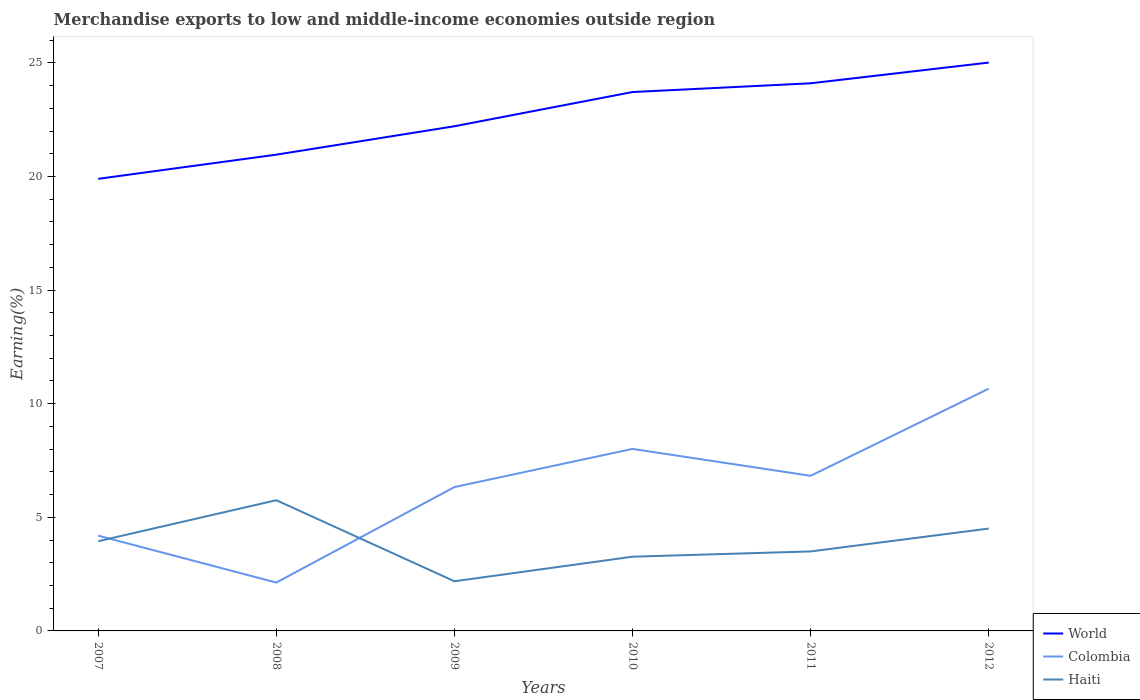Does the line corresponding to Haiti intersect with the line corresponding to World?
Your answer should be compact. No. Is the number of lines equal to the number of legend labels?
Your response must be concise. Yes. Across all years, what is the maximum percentage of amount earned from merchandise exports in Colombia?
Provide a succinct answer. 2.13. What is the total percentage of amount earned from merchandise exports in World in the graph?
Offer a very short reply. -3.82. What is the difference between the highest and the second highest percentage of amount earned from merchandise exports in World?
Your response must be concise. 5.12. What is the difference between the highest and the lowest percentage of amount earned from merchandise exports in Haiti?
Provide a succinct answer. 3. Is the percentage of amount earned from merchandise exports in Haiti strictly greater than the percentage of amount earned from merchandise exports in World over the years?
Provide a short and direct response. Yes. How many lines are there?
Ensure brevity in your answer.  3. Are the values on the major ticks of Y-axis written in scientific E-notation?
Provide a succinct answer. No. What is the title of the graph?
Offer a terse response. Merchandise exports to low and middle-income economies outside region. Does "Hungary" appear as one of the legend labels in the graph?
Offer a terse response. No. What is the label or title of the X-axis?
Give a very brief answer. Years. What is the label or title of the Y-axis?
Give a very brief answer. Earning(%). What is the Earning(%) in World in 2007?
Your answer should be very brief. 19.9. What is the Earning(%) in Colombia in 2007?
Provide a succinct answer. 4.19. What is the Earning(%) of Haiti in 2007?
Provide a succinct answer. 3.95. What is the Earning(%) in World in 2008?
Make the answer very short. 20.96. What is the Earning(%) in Colombia in 2008?
Offer a terse response. 2.13. What is the Earning(%) in Haiti in 2008?
Offer a terse response. 5.75. What is the Earning(%) in World in 2009?
Your answer should be compact. 22.21. What is the Earning(%) in Colombia in 2009?
Make the answer very short. 6.33. What is the Earning(%) in Haiti in 2009?
Provide a short and direct response. 2.19. What is the Earning(%) in World in 2010?
Your response must be concise. 23.72. What is the Earning(%) in Colombia in 2010?
Offer a terse response. 8.01. What is the Earning(%) in Haiti in 2010?
Provide a succinct answer. 3.27. What is the Earning(%) in World in 2011?
Your answer should be very brief. 24.1. What is the Earning(%) of Colombia in 2011?
Your answer should be compact. 6.83. What is the Earning(%) in Haiti in 2011?
Your answer should be compact. 3.5. What is the Earning(%) of World in 2012?
Give a very brief answer. 25.01. What is the Earning(%) in Colombia in 2012?
Your response must be concise. 10.66. What is the Earning(%) in Haiti in 2012?
Make the answer very short. 4.51. Across all years, what is the maximum Earning(%) of World?
Your answer should be compact. 25.01. Across all years, what is the maximum Earning(%) of Colombia?
Your response must be concise. 10.66. Across all years, what is the maximum Earning(%) of Haiti?
Your answer should be very brief. 5.75. Across all years, what is the minimum Earning(%) of World?
Offer a terse response. 19.9. Across all years, what is the minimum Earning(%) of Colombia?
Give a very brief answer. 2.13. Across all years, what is the minimum Earning(%) of Haiti?
Keep it short and to the point. 2.19. What is the total Earning(%) of World in the graph?
Make the answer very short. 135.9. What is the total Earning(%) of Colombia in the graph?
Your response must be concise. 38.15. What is the total Earning(%) of Haiti in the graph?
Make the answer very short. 23.16. What is the difference between the Earning(%) in World in 2007 and that in 2008?
Your answer should be very brief. -1.06. What is the difference between the Earning(%) in Colombia in 2007 and that in 2008?
Make the answer very short. 2.06. What is the difference between the Earning(%) of Haiti in 2007 and that in 2008?
Your response must be concise. -1.8. What is the difference between the Earning(%) of World in 2007 and that in 2009?
Give a very brief answer. -2.31. What is the difference between the Earning(%) of Colombia in 2007 and that in 2009?
Provide a short and direct response. -2.14. What is the difference between the Earning(%) of Haiti in 2007 and that in 2009?
Offer a very short reply. 1.76. What is the difference between the Earning(%) of World in 2007 and that in 2010?
Your response must be concise. -3.82. What is the difference between the Earning(%) of Colombia in 2007 and that in 2010?
Offer a very short reply. -3.82. What is the difference between the Earning(%) of Haiti in 2007 and that in 2010?
Offer a terse response. 0.68. What is the difference between the Earning(%) in World in 2007 and that in 2011?
Make the answer very short. -4.2. What is the difference between the Earning(%) of Colombia in 2007 and that in 2011?
Make the answer very short. -2.63. What is the difference between the Earning(%) of Haiti in 2007 and that in 2011?
Your response must be concise. 0.45. What is the difference between the Earning(%) of World in 2007 and that in 2012?
Keep it short and to the point. -5.12. What is the difference between the Earning(%) in Colombia in 2007 and that in 2012?
Your answer should be very brief. -6.47. What is the difference between the Earning(%) of Haiti in 2007 and that in 2012?
Your response must be concise. -0.56. What is the difference between the Earning(%) of World in 2008 and that in 2009?
Give a very brief answer. -1.25. What is the difference between the Earning(%) in Colombia in 2008 and that in 2009?
Provide a succinct answer. -4.2. What is the difference between the Earning(%) in Haiti in 2008 and that in 2009?
Provide a succinct answer. 3.57. What is the difference between the Earning(%) of World in 2008 and that in 2010?
Keep it short and to the point. -2.76. What is the difference between the Earning(%) in Colombia in 2008 and that in 2010?
Provide a succinct answer. -5.88. What is the difference between the Earning(%) in Haiti in 2008 and that in 2010?
Your answer should be very brief. 2.49. What is the difference between the Earning(%) in World in 2008 and that in 2011?
Offer a terse response. -3.14. What is the difference between the Earning(%) in Colombia in 2008 and that in 2011?
Your answer should be very brief. -4.7. What is the difference between the Earning(%) of Haiti in 2008 and that in 2011?
Your answer should be compact. 2.25. What is the difference between the Earning(%) in World in 2008 and that in 2012?
Provide a succinct answer. -4.05. What is the difference between the Earning(%) of Colombia in 2008 and that in 2012?
Offer a terse response. -8.53. What is the difference between the Earning(%) in Haiti in 2008 and that in 2012?
Provide a short and direct response. 1.25. What is the difference between the Earning(%) in World in 2009 and that in 2010?
Keep it short and to the point. -1.51. What is the difference between the Earning(%) in Colombia in 2009 and that in 2010?
Offer a terse response. -1.68. What is the difference between the Earning(%) of Haiti in 2009 and that in 2010?
Your answer should be compact. -1.08. What is the difference between the Earning(%) in World in 2009 and that in 2011?
Give a very brief answer. -1.89. What is the difference between the Earning(%) of Colombia in 2009 and that in 2011?
Make the answer very short. -0.49. What is the difference between the Earning(%) of Haiti in 2009 and that in 2011?
Give a very brief answer. -1.31. What is the difference between the Earning(%) of World in 2009 and that in 2012?
Make the answer very short. -2.8. What is the difference between the Earning(%) of Colombia in 2009 and that in 2012?
Keep it short and to the point. -4.33. What is the difference between the Earning(%) in Haiti in 2009 and that in 2012?
Your response must be concise. -2.32. What is the difference between the Earning(%) in World in 2010 and that in 2011?
Ensure brevity in your answer.  -0.38. What is the difference between the Earning(%) in Colombia in 2010 and that in 2011?
Provide a succinct answer. 1.18. What is the difference between the Earning(%) of Haiti in 2010 and that in 2011?
Give a very brief answer. -0.23. What is the difference between the Earning(%) of World in 2010 and that in 2012?
Your answer should be very brief. -1.3. What is the difference between the Earning(%) of Colombia in 2010 and that in 2012?
Your answer should be compact. -2.65. What is the difference between the Earning(%) of Haiti in 2010 and that in 2012?
Offer a very short reply. -1.24. What is the difference between the Earning(%) in World in 2011 and that in 2012?
Offer a terse response. -0.91. What is the difference between the Earning(%) of Colombia in 2011 and that in 2012?
Provide a short and direct response. -3.83. What is the difference between the Earning(%) of Haiti in 2011 and that in 2012?
Give a very brief answer. -1.01. What is the difference between the Earning(%) in World in 2007 and the Earning(%) in Colombia in 2008?
Your answer should be very brief. 17.77. What is the difference between the Earning(%) in World in 2007 and the Earning(%) in Haiti in 2008?
Provide a short and direct response. 14.14. What is the difference between the Earning(%) in Colombia in 2007 and the Earning(%) in Haiti in 2008?
Keep it short and to the point. -1.56. What is the difference between the Earning(%) of World in 2007 and the Earning(%) of Colombia in 2009?
Offer a very short reply. 13.57. What is the difference between the Earning(%) in World in 2007 and the Earning(%) in Haiti in 2009?
Keep it short and to the point. 17.71. What is the difference between the Earning(%) in Colombia in 2007 and the Earning(%) in Haiti in 2009?
Your answer should be very brief. 2.01. What is the difference between the Earning(%) in World in 2007 and the Earning(%) in Colombia in 2010?
Ensure brevity in your answer.  11.89. What is the difference between the Earning(%) of World in 2007 and the Earning(%) of Haiti in 2010?
Keep it short and to the point. 16.63. What is the difference between the Earning(%) of Colombia in 2007 and the Earning(%) of Haiti in 2010?
Your answer should be very brief. 0.93. What is the difference between the Earning(%) of World in 2007 and the Earning(%) of Colombia in 2011?
Your answer should be compact. 13.07. What is the difference between the Earning(%) of World in 2007 and the Earning(%) of Haiti in 2011?
Provide a short and direct response. 16.4. What is the difference between the Earning(%) in Colombia in 2007 and the Earning(%) in Haiti in 2011?
Your answer should be very brief. 0.69. What is the difference between the Earning(%) of World in 2007 and the Earning(%) of Colombia in 2012?
Your answer should be very brief. 9.24. What is the difference between the Earning(%) in World in 2007 and the Earning(%) in Haiti in 2012?
Your response must be concise. 15.39. What is the difference between the Earning(%) of Colombia in 2007 and the Earning(%) of Haiti in 2012?
Your answer should be compact. -0.31. What is the difference between the Earning(%) of World in 2008 and the Earning(%) of Colombia in 2009?
Your response must be concise. 14.63. What is the difference between the Earning(%) of World in 2008 and the Earning(%) of Haiti in 2009?
Provide a short and direct response. 18.77. What is the difference between the Earning(%) in Colombia in 2008 and the Earning(%) in Haiti in 2009?
Offer a very short reply. -0.06. What is the difference between the Earning(%) in World in 2008 and the Earning(%) in Colombia in 2010?
Ensure brevity in your answer.  12.95. What is the difference between the Earning(%) in World in 2008 and the Earning(%) in Haiti in 2010?
Your answer should be compact. 17.69. What is the difference between the Earning(%) in Colombia in 2008 and the Earning(%) in Haiti in 2010?
Ensure brevity in your answer.  -1.14. What is the difference between the Earning(%) in World in 2008 and the Earning(%) in Colombia in 2011?
Provide a succinct answer. 14.13. What is the difference between the Earning(%) of World in 2008 and the Earning(%) of Haiti in 2011?
Offer a very short reply. 17.46. What is the difference between the Earning(%) of Colombia in 2008 and the Earning(%) of Haiti in 2011?
Ensure brevity in your answer.  -1.37. What is the difference between the Earning(%) of World in 2008 and the Earning(%) of Haiti in 2012?
Offer a very short reply. 16.45. What is the difference between the Earning(%) of Colombia in 2008 and the Earning(%) of Haiti in 2012?
Give a very brief answer. -2.38. What is the difference between the Earning(%) of World in 2009 and the Earning(%) of Colombia in 2010?
Ensure brevity in your answer.  14.2. What is the difference between the Earning(%) in World in 2009 and the Earning(%) in Haiti in 2010?
Your response must be concise. 18.94. What is the difference between the Earning(%) of Colombia in 2009 and the Earning(%) of Haiti in 2010?
Your answer should be compact. 3.06. What is the difference between the Earning(%) in World in 2009 and the Earning(%) in Colombia in 2011?
Your response must be concise. 15.38. What is the difference between the Earning(%) of World in 2009 and the Earning(%) of Haiti in 2011?
Your answer should be compact. 18.71. What is the difference between the Earning(%) of Colombia in 2009 and the Earning(%) of Haiti in 2011?
Ensure brevity in your answer.  2.83. What is the difference between the Earning(%) of World in 2009 and the Earning(%) of Colombia in 2012?
Keep it short and to the point. 11.55. What is the difference between the Earning(%) in World in 2009 and the Earning(%) in Haiti in 2012?
Ensure brevity in your answer.  17.71. What is the difference between the Earning(%) in Colombia in 2009 and the Earning(%) in Haiti in 2012?
Ensure brevity in your answer.  1.83. What is the difference between the Earning(%) in World in 2010 and the Earning(%) in Colombia in 2011?
Your answer should be compact. 16.89. What is the difference between the Earning(%) in World in 2010 and the Earning(%) in Haiti in 2011?
Keep it short and to the point. 20.22. What is the difference between the Earning(%) of Colombia in 2010 and the Earning(%) of Haiti in 2011?
Give a very brief answer. 4.51. What is the difference between the Earning(%) in World in 2010 and the Earning(%) in Colombia in 2012?
Your answer should be very brief. 13.06. What is the difference between the Earning(%) in World in 2010 and the Earning(%) in Haiti in 2012?
Your answer should be compact. 19.21. What is the difference between the Earning(%) in Colombia in 2010 and the Earning(%) in Haiti in 2012?
Give a very brief answer. 3.51. What is the difference between the Earning(%) in World in 2011 and the Earning(%) in Colombia in 2012?
Your answer should be compact. 13.44. What is the difference between the Earning(%) in World in 2011 and the Earning(%) in Haiti in 2012?
Provide a succinct answer. 19.6. What is the difference between the Earning(%) in Colombia in 2011 and the Earning(%) in Haiti in 2012?
Provide a short and direct response. 2.32. What is the average Earning(%) in World per year?
Keep it short and to the point. 22.65. What is the average Earning(%) in Colombia per year?
Provide a short and direct response. 6.36. What is the average Earning(%) of Haiti per year?
Ensure brevity in your answer.  3.86. In the year 2007, what is the difference between the Earning(%) of World and Earning(%) of Colombia?
Ensure brevity in your answer.  15.7. In the year 2007, what is the difference between the Earning(%) in World and Earning(%) in Haiti?
Give a very brief answer. 15.95. In the year 2007, what is the difference between the Earning(%) of Colombia and Earning(%) of Haiti?
Your answer should be very brief. 0.24. In the year 2008, what is the difference between the Earning(%) in World and Earning(%) in Colombia?
Offer a terse response. 18.83. In the year 2008, what is the difference between the Earning(%) in World and Earning(%) in Haiti?
Ensure brevity in your answer.  15.21. In the year 2008, what is the difference between the Earning(%) of Colombia and Earning(%) of Haiti?
Keep it short and to the point. -3.62. In the year 2009, what is the difference between the Earning(%) in World and Earning(%) in Colombia?
Ensure brevity in your answer.  15.88. In the year 2009, what is the difference between the Earning(%) of World and Earning(%) of Haiti?
Give a very brief answer. 20.02. In the year 2009, what is the difference between the Earning(%) of Colombia and Earning(%) of Haiti?
Provide a succinct answer. 4.15. In the year 2010, what is the difference between the Earning(%) of World and Earning(%) of Colombia?
Your answer should be very brief. 15.71. In the year 2010, what is the difference between the Earning(%) of World and Earning(%) of Haiti?
Keep it short and to the point. 20.45. In the year 2010, what is the difference between the Earning(%) of Colombia and Earning(%) of Haiti?
Your response must be concise. 4.74. In the year 2011, what is the difference between the Earning(%) of World and Earning(%) of Colombia?
Ensure brevity in your answer.  17.27. In the year 2011, what is the difference between the Earning(%) in World and Earning(%) in Haiti?
Ensure brevity in your answer.  20.6. In the year 2011, what is the difference between the Earning(%) in Colombia and Earning(%) in Haiti?
Ensure brevity in your answer.  3.33. In the year 2012, what is the difference between the Earning(%) of World and Earning(%) of Colombia?
Keep it short and to the point. 14.35. In the year 2012, what is the difference between the Earning(%) of World and Earning(%) of Haiti?
Ensure brevity in your answer.  20.51. In the year 2012, what is the difference between the Earning(%) in Colombia and Earning(%) in Haiti?
Your answer should be compact. 6.15. What is the ratio of the Earning(%) of World in 2007 to that in 2008?
Provide a succinct answer. 0.95. What is the ratio of the Earning(%) in Colombia in 2007 to that in 2008?
Provide a short and direct response. 1.97. What is the ratio of the Earning(%) of Haiti in 2007 to that in 2008?
Ensure brevity in your answer.  0.69. What is the ratio of the Earning(%) in World in 2007 to that in 2009?
Your answer should be compact. 0.9. What is the ratio of the Earning(%) in Colombia in 2007 to that in 2009?
Ensure brevity in your answer.  0.66. What is the ratio of the Earning(%) in Haiti in 2007 to that in 2009?
Offer a very short reply. 1.81. What is the ratio of the Earning(%) of World in 2007 to that in 2010?
Keep it short and to the point. 0.84. What is the ratio of the Earning(%) of Colombia in 2007 to that in 2010?
Offer a very short reply. 0.52. What is the ratio of the Earning(%) of Haiti in 2007 to that in 2010?
Provide a short and direct response. 1.21. What is the ratio of the Earning(%) in World in 2007 to that in 2011?
Make the answer very short. 0.83. What is the ratio of the Earning(%) of Colombia in 2007 to that in 2011?
Your answer should be compact. 0.61. What is the ratio of the Earning(%) in Haiti in 2007 to that in 2011?
Your response must be concise. 1.13. What is the ratio of the Earning(%) of World in 2007 to that in 2012?
Make the answer very short. 0.8. What is the ratio of the Earning(%) of Colombia in 2007 to that in 2012?
Your response must be concise. 0.39. What is the ratio of the Earning(%) in Haiti in 2007 to that in 2012?
Your answer should be very brief. 0.88. What is the ratio of the Earning(%) of World in 2008 to that in 2009?
Your answer should be very brief. 0.94. What is the ratio of the Earning(%) of Colombia in 2008 to that in 2009?
Your answer should be very brief. 0.34. What is the ratio of the Earning(%) of Haiti in 2008 to that in 2009?
Ensure brevity in your answer.  2.63. What is the ratio of the Earning(%) of World in 2008 to that in 2010?
Make the answer very short. 0.88. What is the ratio of the Earning(%) of Colombia in 2008 to that in 2010?
Ensure brevity in your answer.  0.27. What is the ratio of the Earning(%) in Haiti in 2008 to that in 2010?
Make the answer very short. 1.76. What is the ratio of the Earning(%) of World in 2008 to that in 2011?
Make the answer very short. 0.87. What is the ratio of the Earning(%) of Colombia in 2008 to that in 2011?
Ensure brevity in your answer.  0.31. What is the ratio of the Earning(%) of Haiti in 2008 to that in 2011?
Keep it short and to the point. 1.64. What is the ratio of the Earning(%) in World in 2008 to that in 2012?
Make the answer very short. 0.84. What is the ratio of the Earning(%) in Colombia in 2008 to that in 2012?
Your response must be concise. 0.2. What is the ratio of the Earning(%) in Haiti in 2008 to that in 2012?
Make the answer very short. 1.28. What is the ratio of the Earning(%) of World in 2009 to that in 2010?
Give a very brief answer. 0.94. What is the ratio of the Earning(%) in Colombia in 2009 to that in 2010?
Provide a succinct answer. 0.79. What is the ratio of the Earning(%) in Haiti in 2009 to that in 2010?
Provide a succinct answer. 0.67. What is the ratio of the Earning(%) in World in 2009 to that in 2011?
Your answer should be very brief. 0.92. What is the ratio of the Earning(%) of Colombia in 2009 to that in 2011?
Keep it short and to the point. 0.93. What is the ratio of the Earning(%) in Haiti in 2009 to that in 2011?
Provide a short and direct response. 0.62. What is the ratio of the Earning(%) in World in 2009 to that in 2012?
Ensure brevity in your answer.  0.89. What is the ratio of the Earning(%) in Colombia in 2009 to that in 2012?
Provide a succinct answer. 0.59. What is the ratio of the Earning(%) in Haiti in 2009 to that in 2012?
Offer a terse response. 0.49. What is the ratio of the Earning(%) in Colombia in 2010 to that in 2011?
Provide a short and direct response. 1.17. What is the ratio of the Earning(%) in Haiti in 2010 to that in 2011?
Provide a succinct answer. 0.93. What is the ratio of the Earning(%) of World in 2010 to that in 2012?
Your answer should be compact. 0.95. What is the ratio of the Earning(%) of Colombia in 2010 to that in 2012?
Your response must be concise. 0.75. What is the ratio of the Earning(%) of Haiti in 2010 to that in 2012?
Offer a terse response. 0.73. What is the ratio of the Earning(%) in World in 2011 to that in 2012?
Your response must be concise. 0.96. What is the ratio of the Earning(%) in Colombia in 2011 to that in 2012?
Provide a succinct answer. 0.64. What is the ratio of the Earning(%) in Haiti in 2011 to that in 2012?
Make the answer very short. 0.78. What is the difference between the highest and the second highest Earning(%) of World?
Make the answer very short. 0.91. What is the difference between the highest and the second highest Earning(%) of Colombia?
Keep it short and to the point. 2.65. What is the difference between the highest and the second highest Earning(%) in Haiti?
Your answer should be compact. 1.25. What is the difference between the highest and the lowest Earning(%) in World?
Offer a terse response. 5.12. What is the difference between the highest and the lowest Earning(%) of Colombia?
Provide a short and direct response. 8.53. What is the difference between the highest and the lowest Earning(%) in Haiti?
Your answer should be compact. 3.57. 